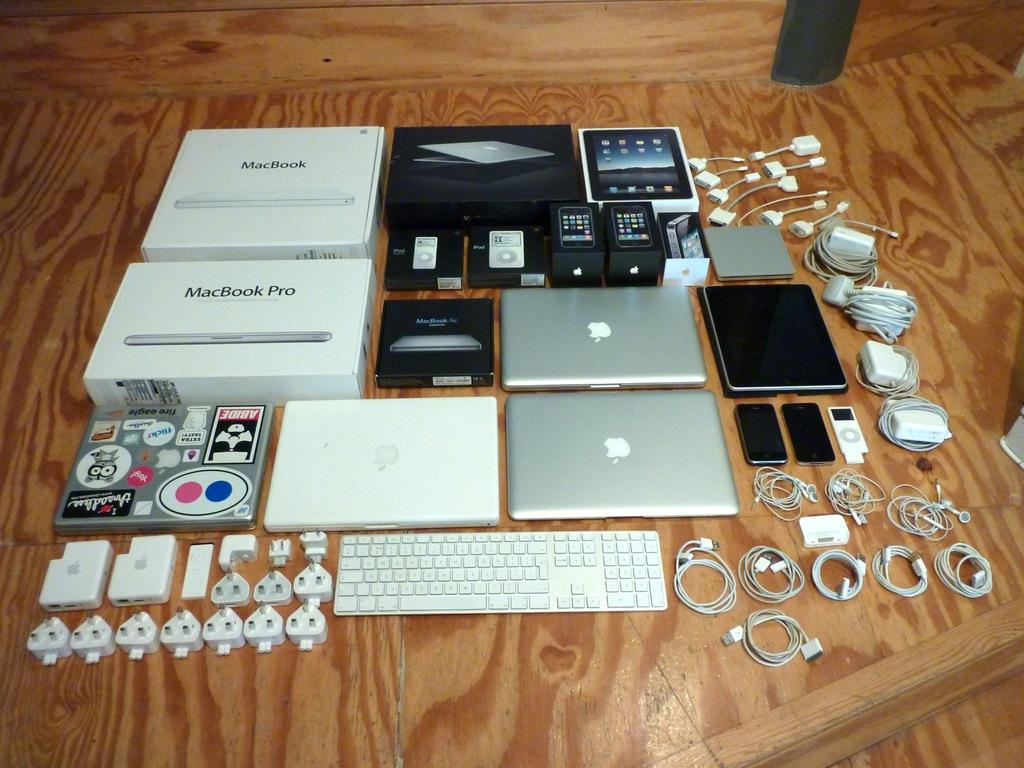<image>
Describe the image concisely. Some macbook pro boxes, laptops and accessories are spread out. 